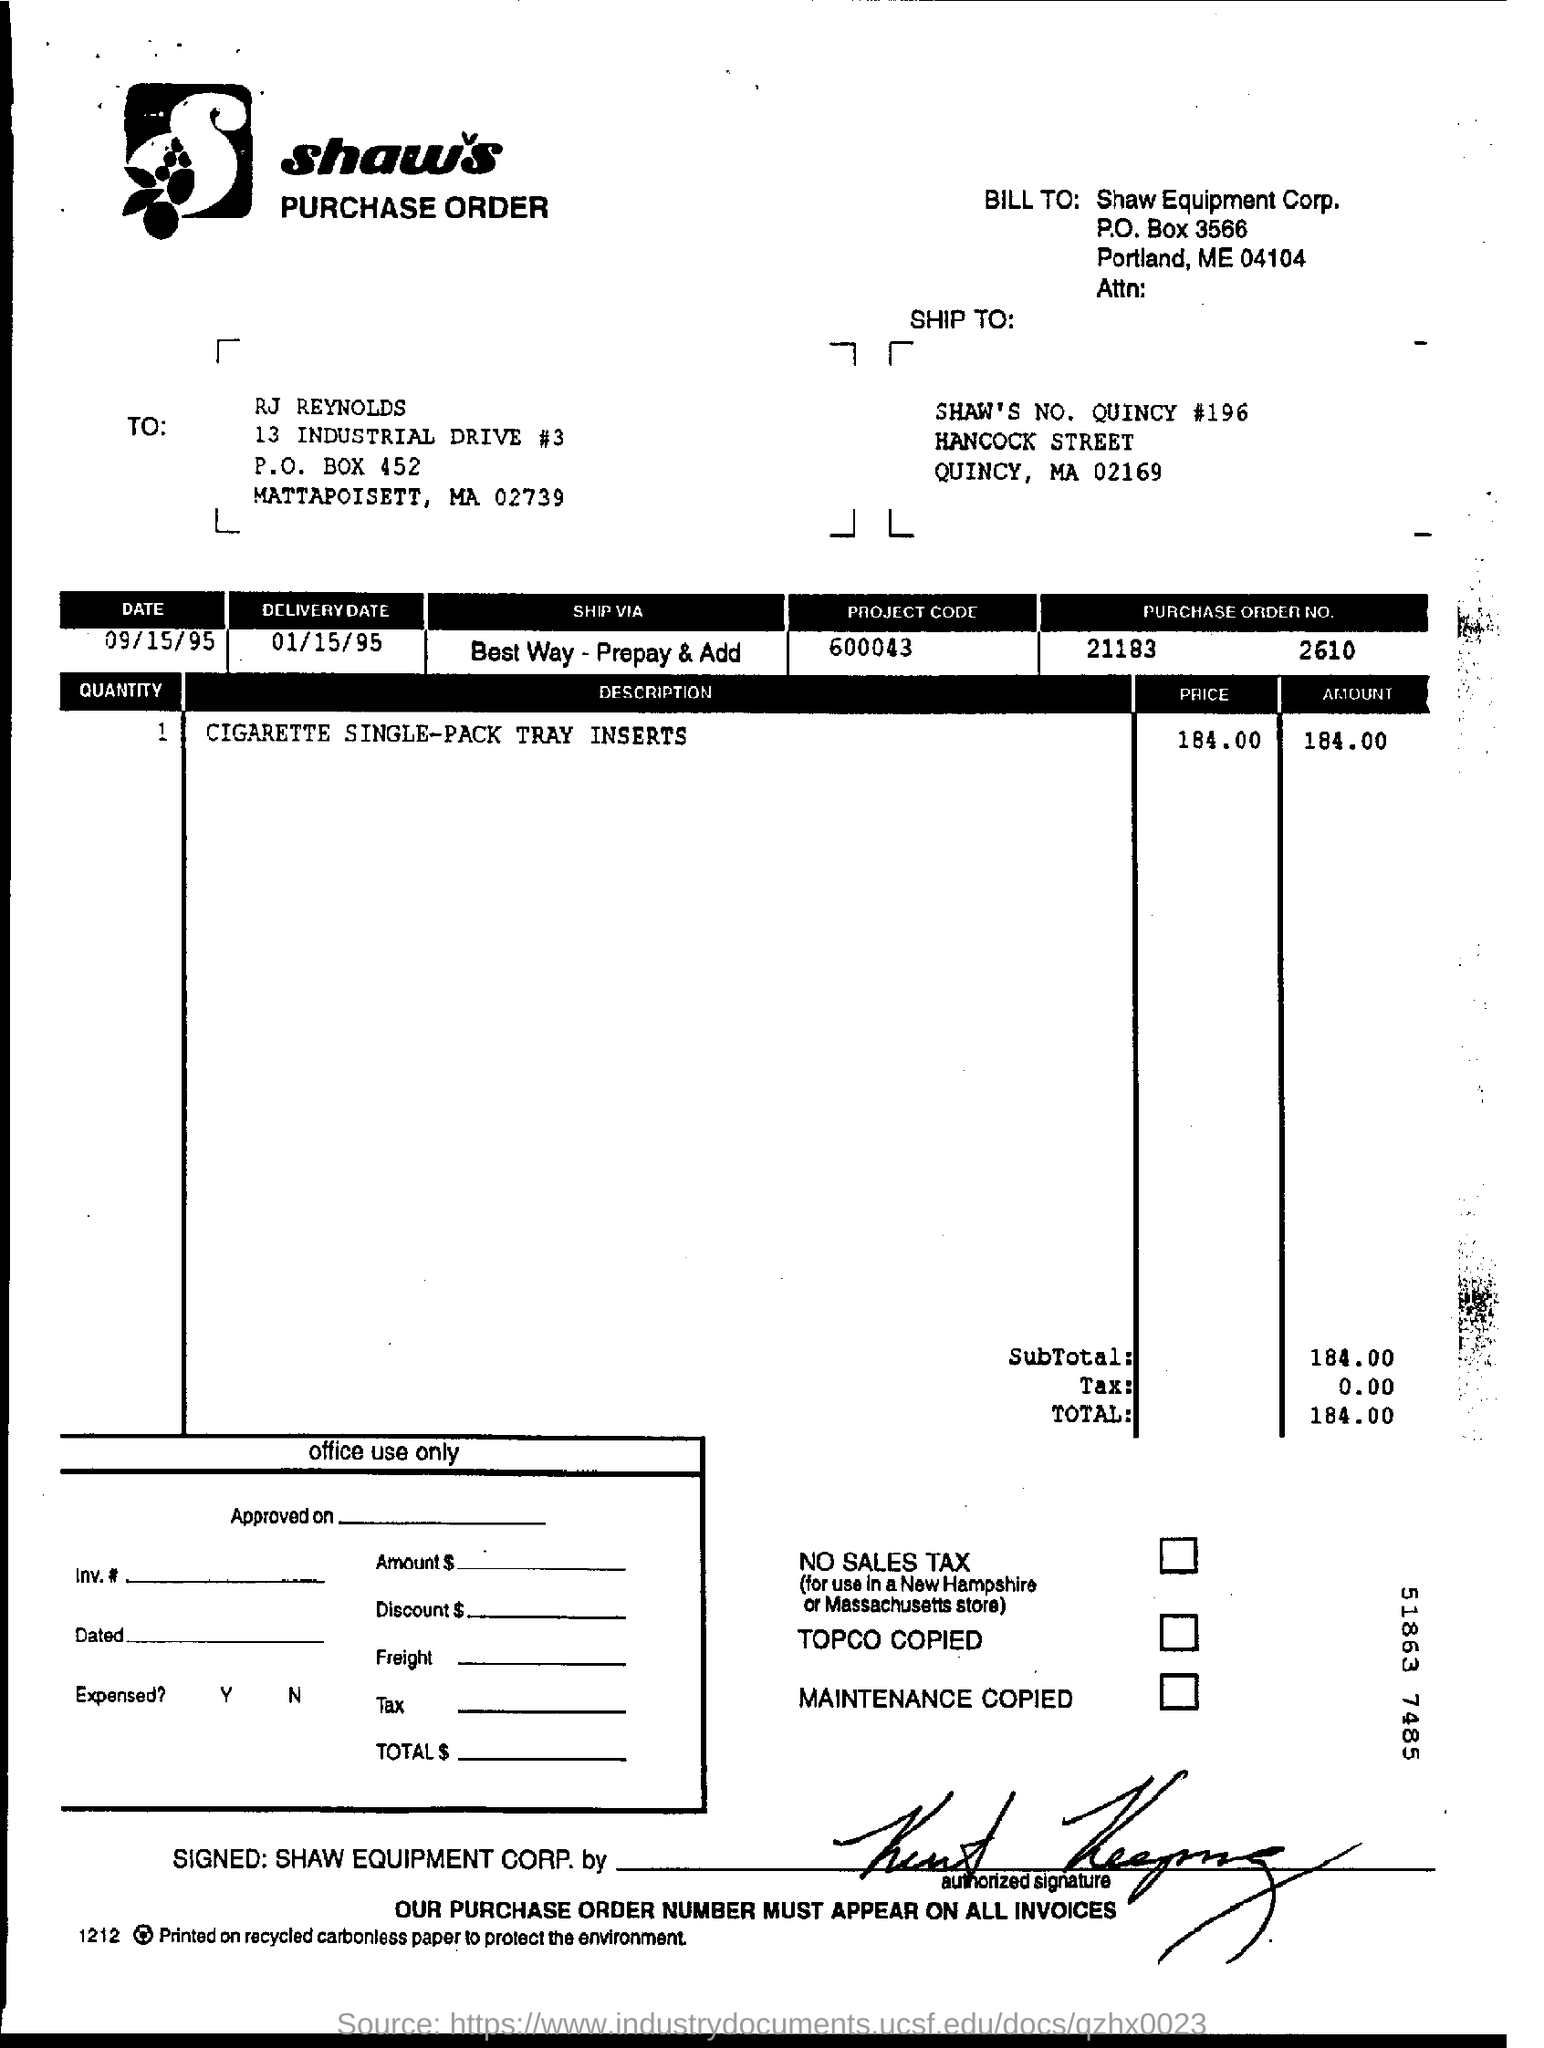What is the p.o box number?
Provide a succinct answer. 3566. What is the delivery date?
Make the answer very short. 01/15/95. What is the project code?
Ensure brevity in your answer.  600043. What is the purchase order number?
Your response must be concise. 21183       2610. 